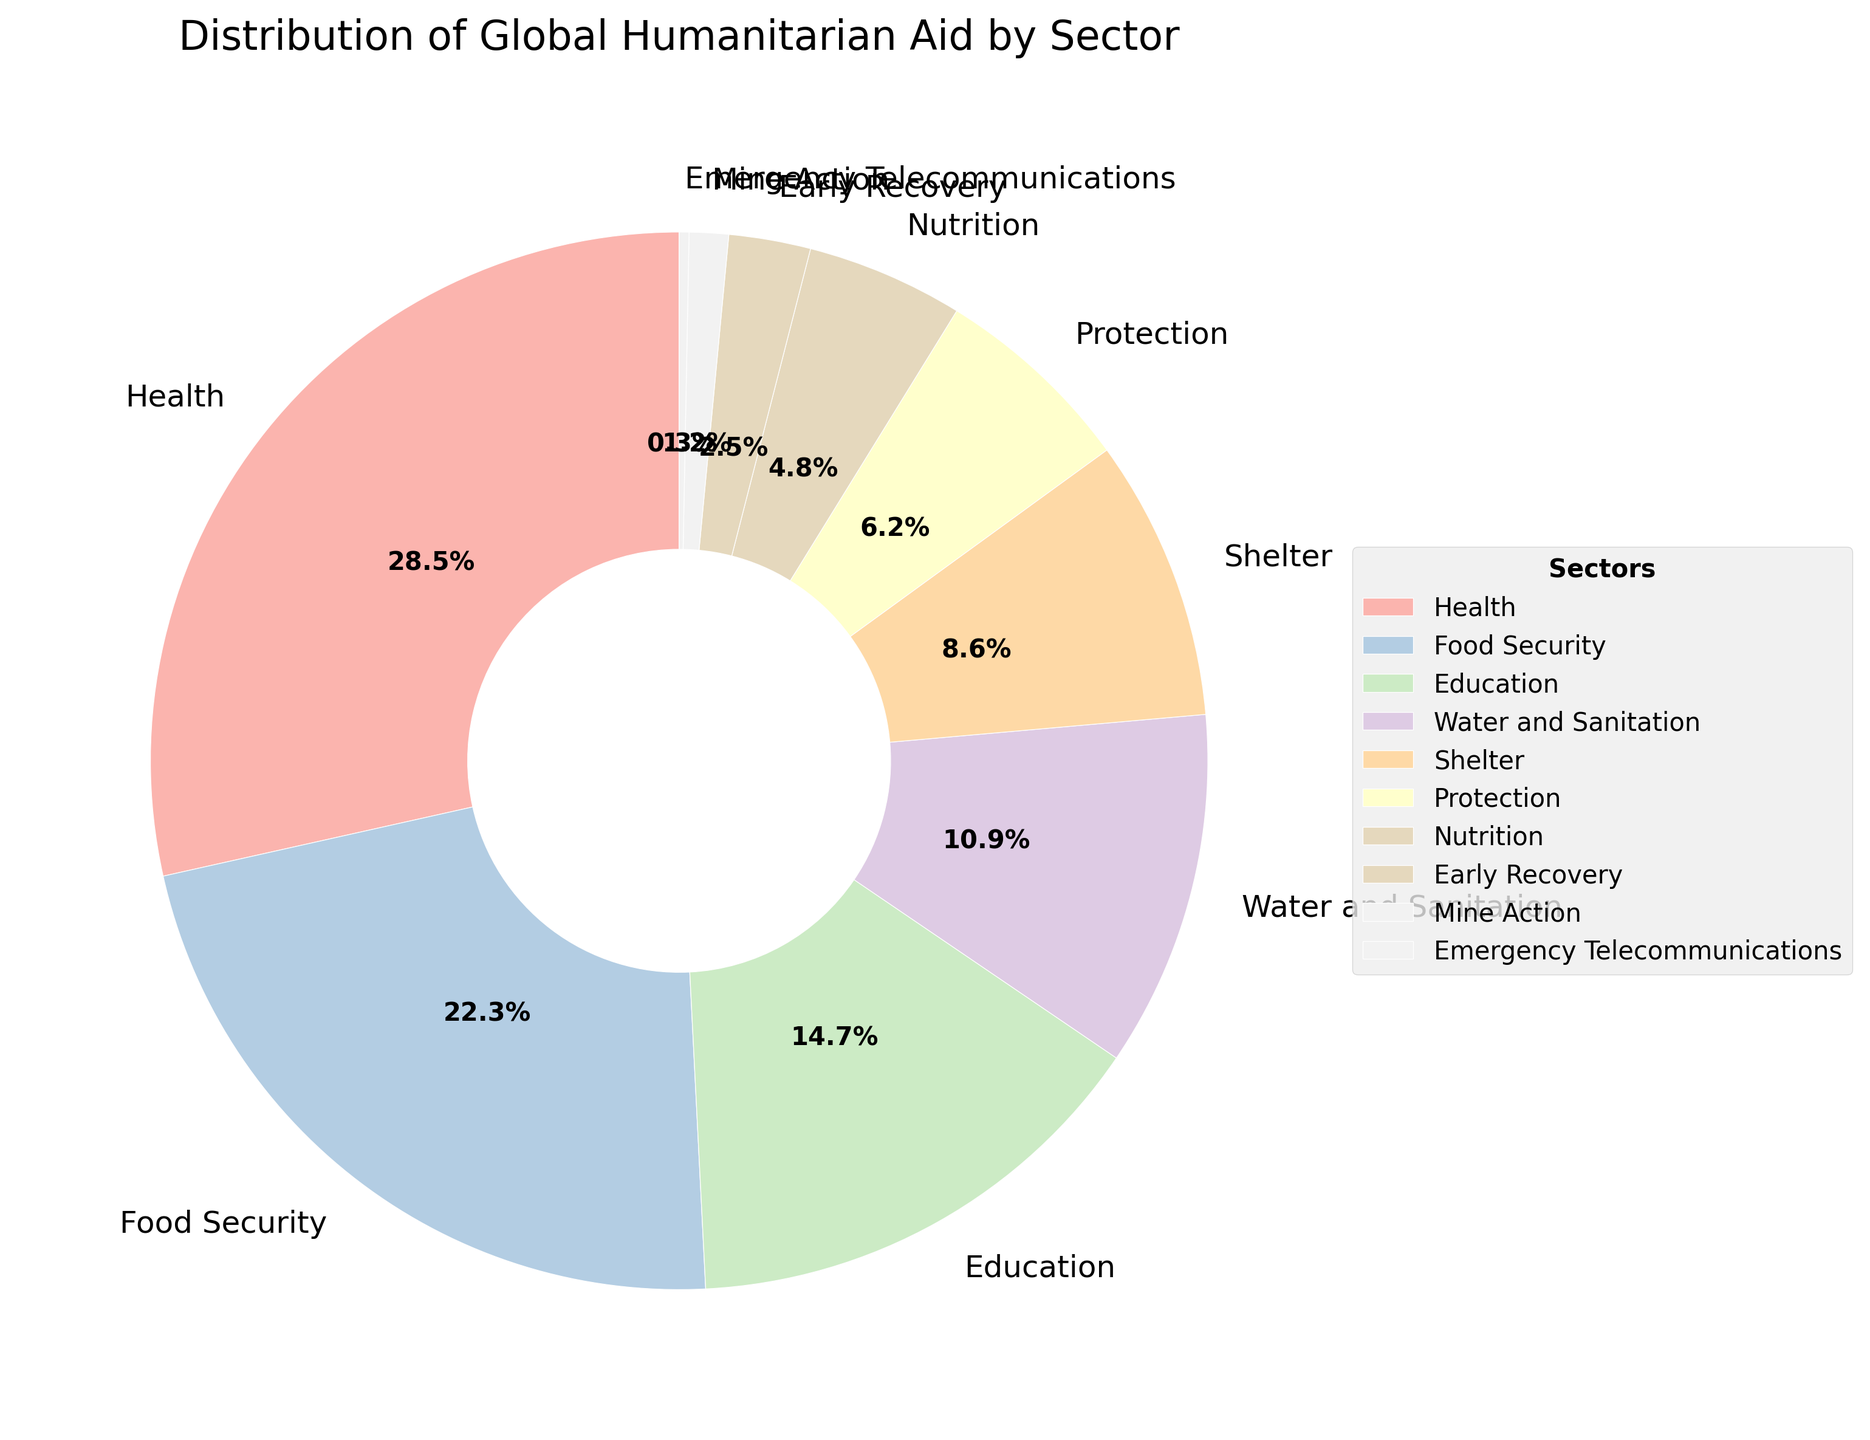What percentage of global humanitarian aid is allocated to the Health sector? Locate the "Health" portion of the pie chart, then refer to the percentage label next to it.
Answer: 28.5% Which sector receives more aid, Education or Shelter? Find the sections labeled "Education" and "Shelter" on the pie chart and compare their percentages. Education (14.7%) is higher than Shelter (8.6%).
Answer: Education How much more aid does Food Security receive compared to Water and Sanitation? Locate the percentages for "Food Security" and "Water and Sanitation". Subtract the percentage of Water and Sanitation (10.9%) from Food Security (22.3%): 22.3% - 10.9% = 11.4%.
Answer: 11.4% What is the combined percentage of aid allocated to Protection and Nutrition sectors? Find the percentages for "Protection" (6.2%) and "Nutrition" (4.8%) and sum them up: 6.2% + 4.8% = 11.0%.
Answer: 11.0% Which sector receives the least amount of global humanitarian aid? Identify the smallest wedge in the pie chart, which is labeled "Emergency Telecommunications" with 0.3%.
Answer: Emergency Telecommunications How many sectors have a percentage allocation greater than 10%? Identify wedges with percentages greater than 10%: Health (28.5%), Food Security (22.3%), Education (14.7%), and Water and Sanitation (10.9%). There are four such sectors.
Answer: 4 Is the percentage of aid allocated to Shelter more or less than half of that allocated to Health? Compare the percentage of Shelter (8.6%) to half of Health (28.5% / 2 = 14.25%). Since 8.6% is less than 14.25%, the answer is less.
Answer: Less What is the total percentage of aid allocated to sectors related to essential living needs (Food Security, Shelter, Water and Sanitation)? Sum the percentages for "Food Security" (22.3%), "Shelter" (8.6%), and "Water and Sanitation" (10.9%): 22.3% + 8.6% + 10.9% = 41.8%.
Answer: 41.8% By how much does the aid for Health exceed the combined aid for Nutrition and Early Recovery? Calculate the combined percentage for "Nutrition" (4.8%) and "Early Recovery" (2.5%): 4.8% + 2.5% = 7.3%. Subtract this from the percentage for "Health" (28.5%): 28.5% - 7.3% = 21.2%.
Answer: 21.2% 